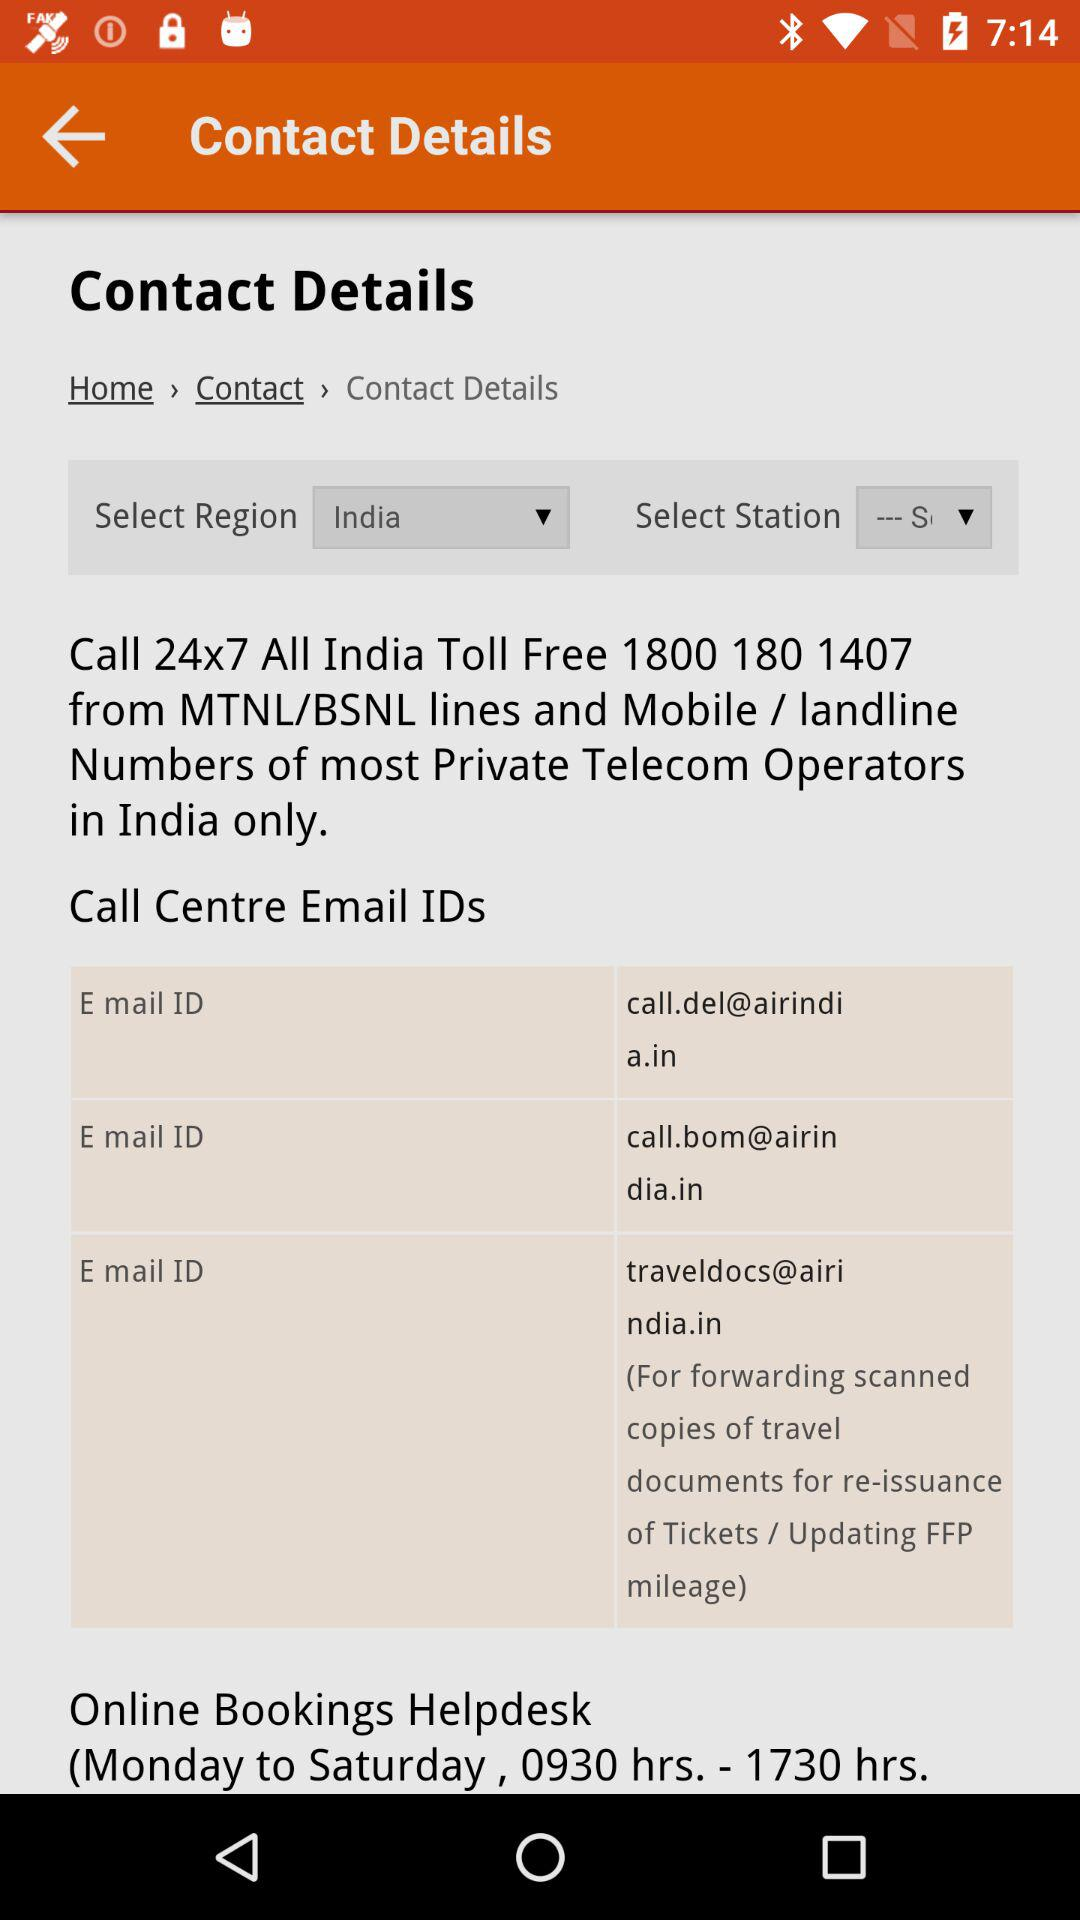What are the timings for the online bookings helpdesk? The timings for the online bookings helpdesk are Monday to Saturday from 09:30 AM to 05:30 PM. 